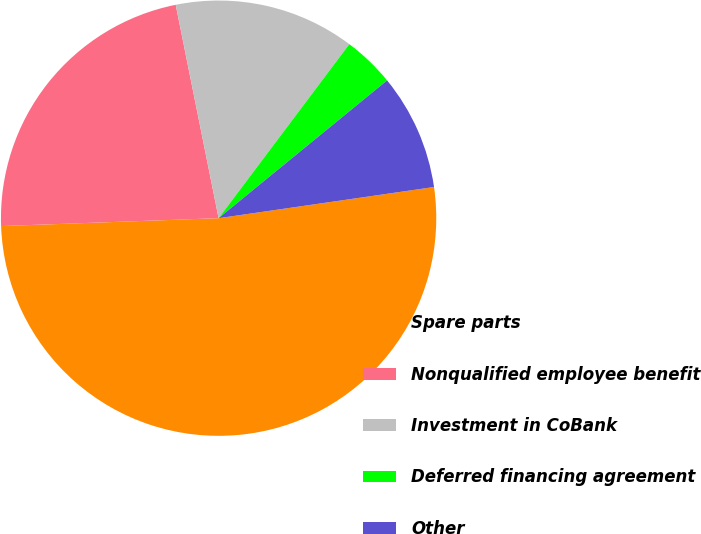Convert chart. <chart><loc_0><loc_0><loc_500><loc_500><pie_chart><fcel>Spare parts<fcel>Nonqualified employee benefit<fcel>Investment in CoBank<fcel>Deferred financing agreement<fcel>Other<nl><fcel>51.71%<fcel>22.42%<fcel>13.41%<fcel>3.84%<fcel>8.62%<nl></chart> 